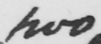What does this handwritten line say? two 